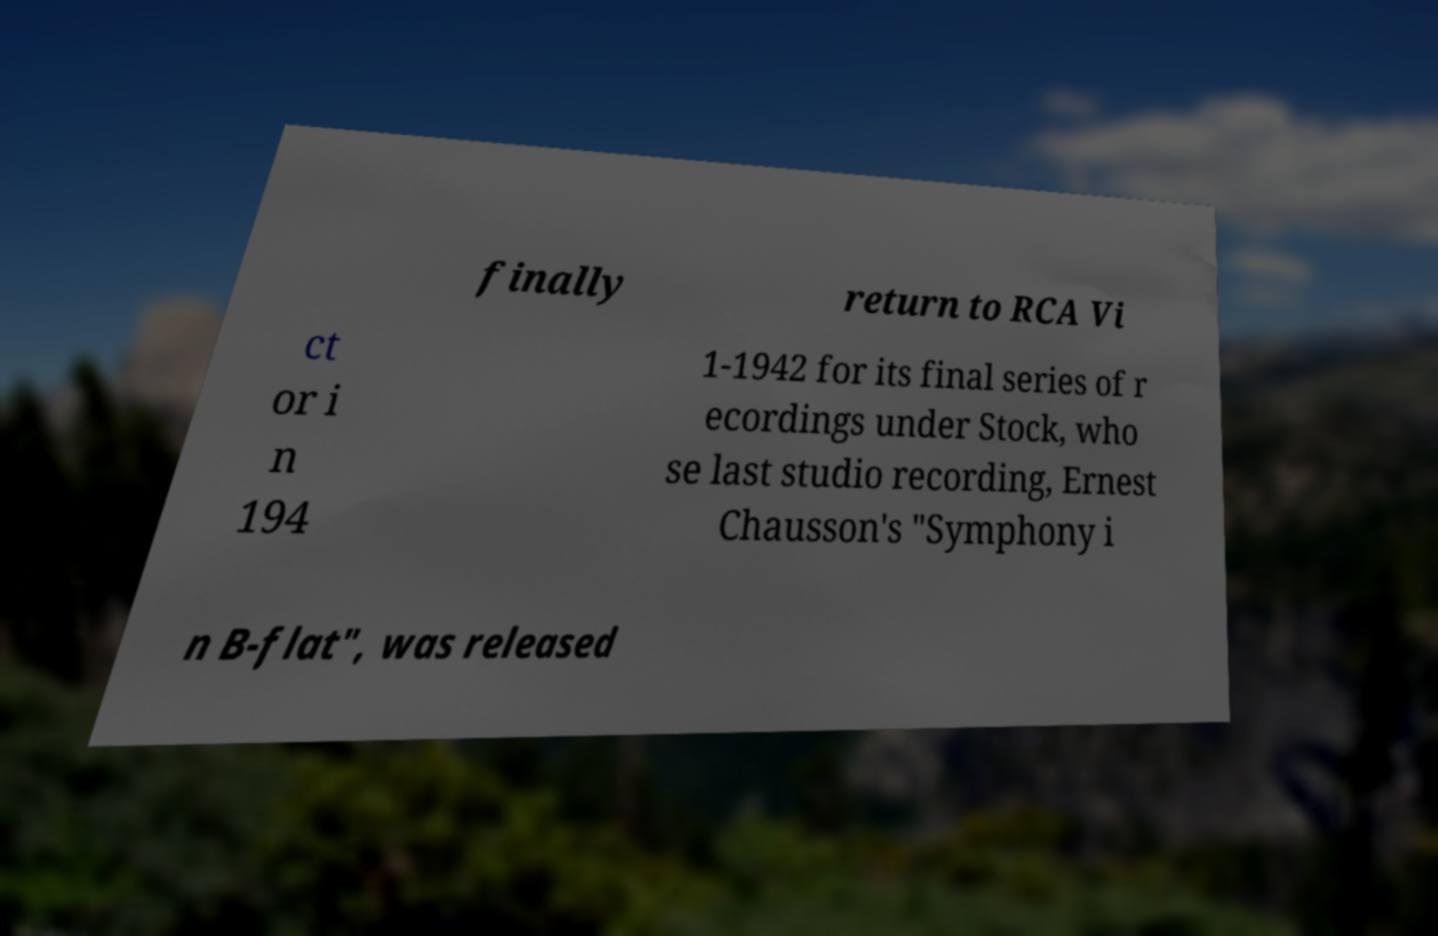For documentation purposes, I need the text within this image transcribed. Could you provide that? finally return to RCA Vi ct or i n 194 1-1942 for its final series of r ecordings under Stock, who se last studio recording, Ernest Chausson's "Symphony i n B-flat", was released 